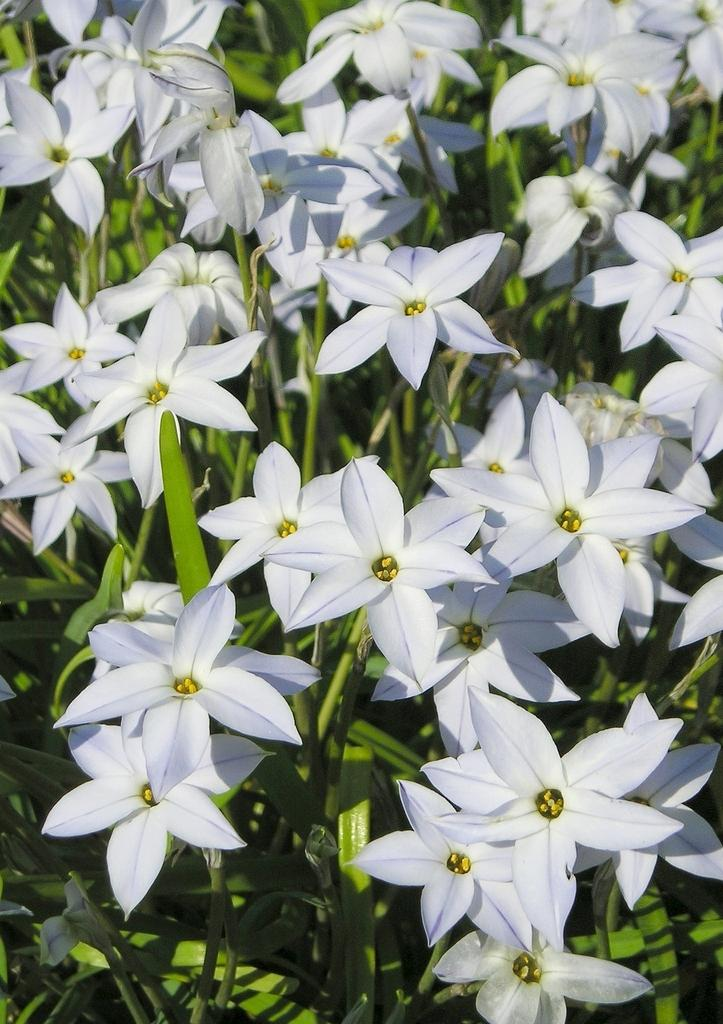What type of living organisms can be seen in the image? There are flowers and plants visible in the image. Can you describe the plants in the image? The plants in the image are not specified, but they are present alongside the flowers. How many children are playing with the birds in the image? There are no children or birds present in the image; it only features flowers and plants. 